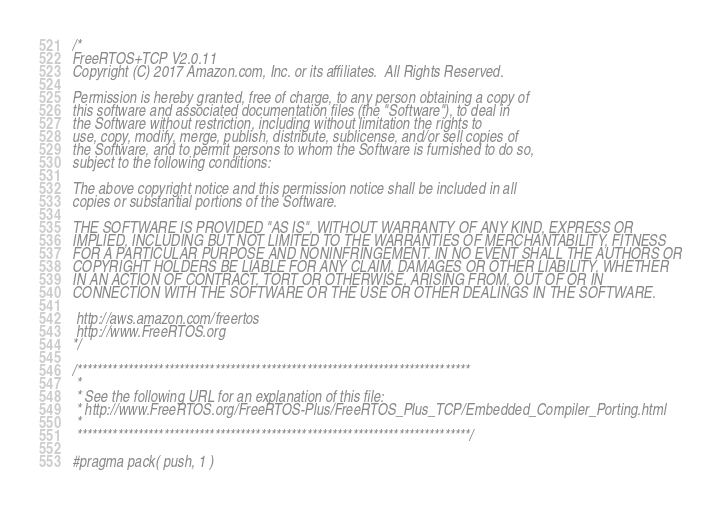Convert code to text. <code><loc_0><loc_0><loc_500><loc_500><_C_>/*
FreeRTOS+TCP V2.0.11
Copyright (C) 2017 Amazon.com, Inc. or its affiliates.  All Rights Reserved.

Permission is hereby granted, free of charge, to any person obtaining a copy of
this software and associated documentation files (the "Software"), to deal in
the Software without restriction, including without limitation the rights to
use, copy, modify, merge, publish, distribute, sublicense, and/or sell copies of
the Software, and to permit persons to whom the Software is furnished to do so,
subject to the following conditions:

The above copyright notice and this permission notice shall be included in all
copies or substantial portions of the Software.

THE SOFTWARE IS PROVIDED "AS IS", WITHOUT WARRANTY OF ANY KIND, EXPRESS OR
IMPLIED, INCLUDING BUT NOT LIMITED TO THE WARRANTIES OF MERCHANTABILITY, FITNESS
FOR A PARTICULAR PURPOSE AND NONINFRINGEMENT. IN NO EVENT SHALL THE AUTHORS OR
COPYRIGHT HOLDERS BE LIABLE FOR ANY CLAIM, DAMAGES OR OTHER LIABILITY, WHETHER
IN AN ACTION OF CONTRACT, TORT OR OTHERWISE, ARISING FROM, OUT OF OR IN
CONNECTION WITH THE SOFTWARE OR THE USE OR OTHER DEALINGS IN THE SOFTWARE.

 http://aws.amazon.com/freertos
 http://www.FreeRTOS.org
*/

/*****************************************************************************
 *
 * See the following URL for an explanation of this file:
 * http://www.FreeRTOS.org/FreeRTOS-Plus/FreeRTOS_Plus_TCP/Embedded_Compiler_Porting.html
 *
 *****************************************************************************/

#pragma pack( push, 1 )
</code> 